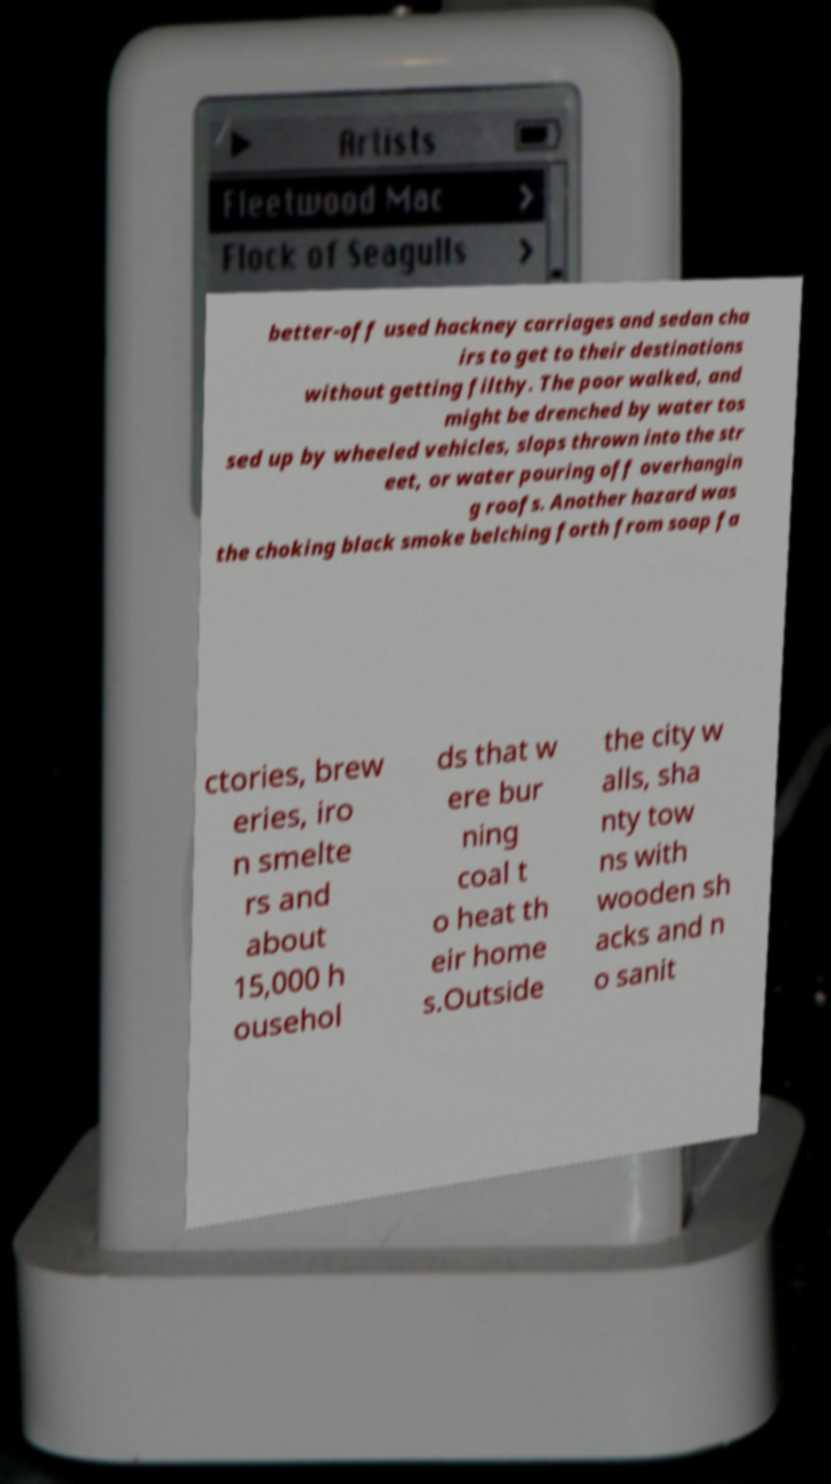I need the written content from this picture converted into text. Can you do that? better-off used hackney carriages and sedan cha irs to get to their destinations without getting filthy. The poor walked, and might be drenched by water tos sed up by wheeled vehicles, slops thrown into the str eet, or water pouring off overhangin g roofs. Another hazard was the choking black smoke belching forth from soap fa ctories, brew eries, iro n smelte rs and about 15,000 h ousehol ds that w ere bur ning coal t o heat th eir home s.Outside the city w alls, sha nty tow ns with wooden sh acks and n o sanit 